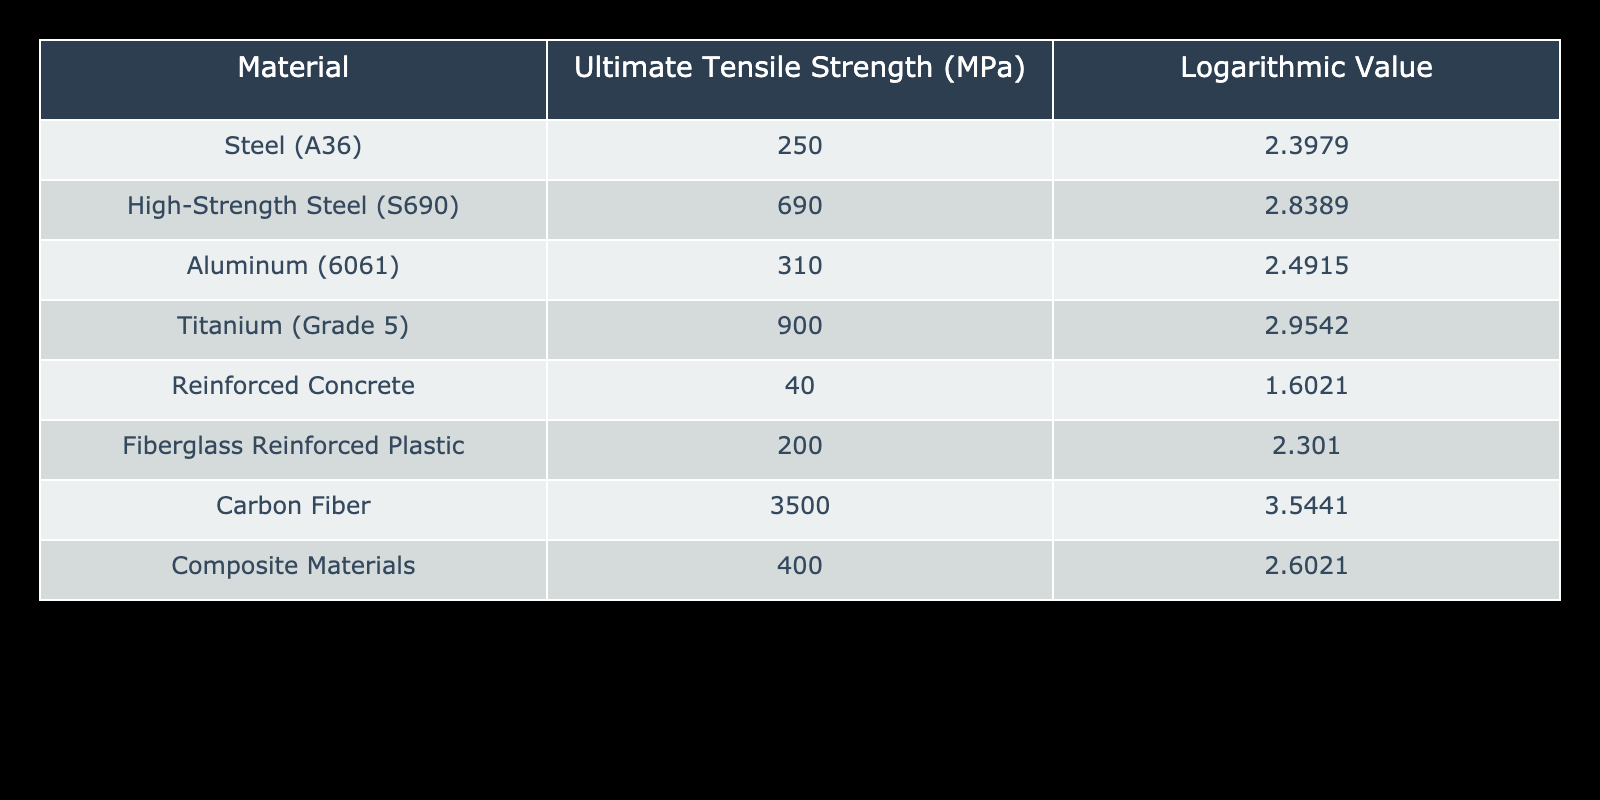What is the ultimate tensile strength of Titanium (Grade 5)? According to the table, the ultimate tensile strength of Titanium (Grade 5) is listed as 900 MPa.
Answer: 900 MPa Which material has the highest ultimate tensile strength? By examining the values in the ultimate tensile strength column, Carbon Fiber has the highest value at 3500 MPa, which is greater than all other materials listed.
Answer: Carbon Fiber What is the logarithmic value of High-Strength Steel (S690)? In the table, the logarithmic value corresponding to High-Strength Steel (S690) is shown as 2.8389.
Answer: 2.8389 Is the ultimate tensile strength of Fiberglass Reinforced Plastic greater than that of Reinforced Concrete? Looking at the ultimate tensile strength values, Fiberglass Reinforced Plastic has an ultimate tensile strength of 200 MPa, while Reinforced Concrete has a much lower strength of 40 MPa. Therefore, Fiberglass Reinforced Plastic is indeed stronger.
Answer: Yes What is the average ultimate tensile strength of the materials listed? To find the average, first sum the ultimate tensile strength values: 250 + 690 + 310 + 900 + 40 + 200 + 3500 + 400 = 5290 MPa. There are 8 materials listed, so the average is 5290/8 = 661.25 MPa.
Answer: 661.25 MPa If you replace Steel (A36) with Titanium (Grade 5) in a structure, how much stronger will that section be using ultimate tensile strength values? Steel (A36) has a strength of 250 MPa and Titanium (Grade 5) has a strength of 900 MPa. The difference is 900 - 250 = 650 MPa, indicating a significant increase in strength if Steel (A36) is replaced with Titanium (Grade 5).
Answer: 650 MPa Does Composite Materials have a higher tensile strength than Aluminum (6061)? Comparing the ultimate tensile strength values in the table, Composite Materials has a tensile strength of 400 MPa while Aluminum (6061) is at 310 MPa. Therefore, Composite Materials is stronger.
Answer: Yes What is the difference in logarithmic values between Carbon Fiber and Aluminum (6061)? The logarithmic value of Carbon Fiber is 3.5441 and that of Aluminum (6061) is 2.4915. The difference is 3.5441 - 2.4915 = 1.0526.
Answer: 1.0526 